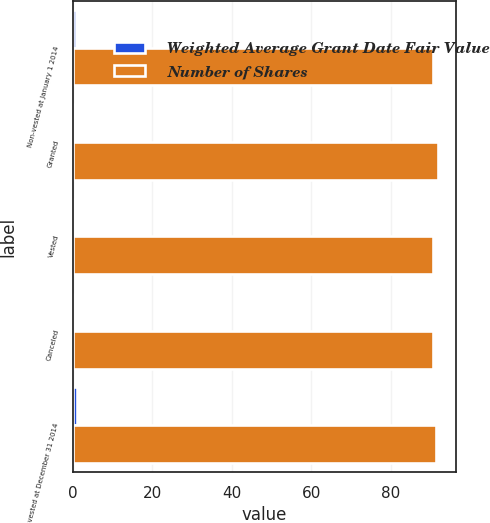Convert chart to OTSL. <chart><loc_0><loc_0><loc_500><loc_500><stacked_bar_chart><ecel><fcel>Non-vested at January 1 2014<fcel>Granted<fcel>Vested<fcel>Canceled<fcel>Non-vested at December 31 2014<nl><fcel>Weighted Average Grant Date Fair Value<fcel>0.8<fcel>0.6<fcel>0.2<fcel>0.1<fcel>1.1<nl><fcel>Number of Shares<fcel>90.7<fcel>91.77<fcel>90.62<fcel>90.61<fcel>91.3<nl></chart> 